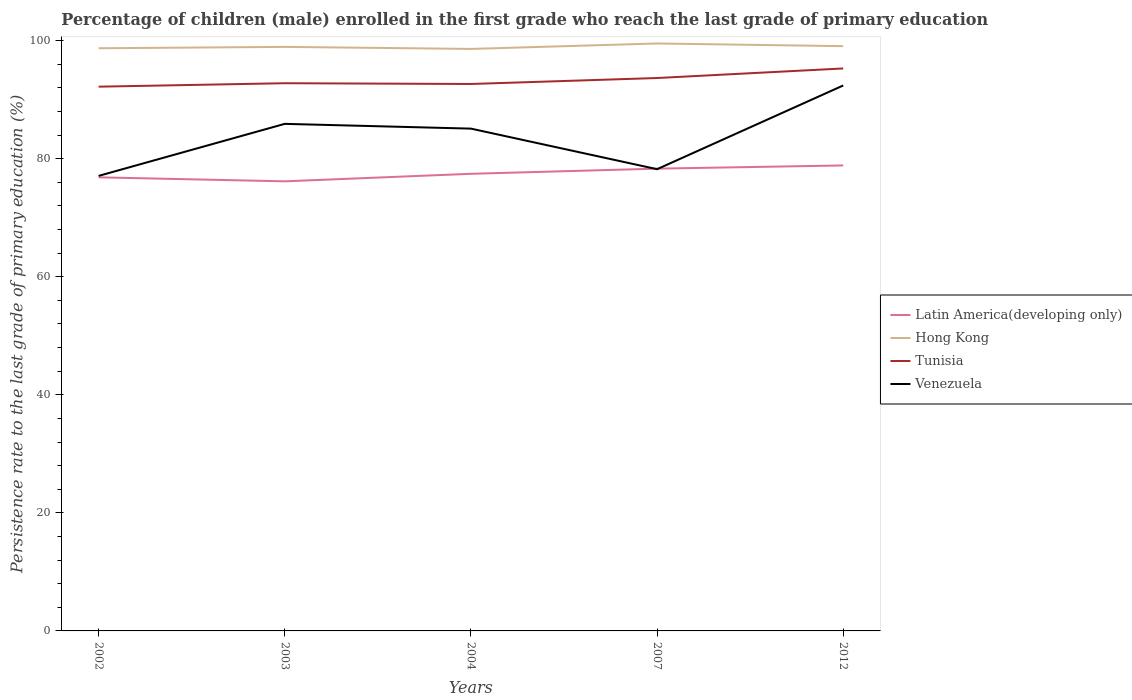Does the line corresponding to Venezuela intersect with the line corresponding to Latin America(developing only)?
Your answer should be very brief. Yes. Is the number of lines equal to the number of legend labels?
Offer a terse response. Yes. Across all years, what is the maximum persistence rate of children in Latin America(developing only)?
Keep it short and to the point. 76.17. What is the total persistence rate of children in Hong Kong in the graph?
Provide a succinct answer. -0.47. What is the difference between the highest and the second highest persistence rate of children in Tunisia?
Offer a terse response. 3.09. What is the difference between the highest and the lowest persistence rate of children in Hong Kong?
Ensure brevity in your answer.  2. Is the persistence rate of children in Latin America(developing only) strictly greater than the persistence rate of children in Venezuela over the years?
Offer a terse response. No. Are the values on the major ticks of Y-axis written in scientific E-notation?
Provide a succinct answer. No. Does the graph contain any zero values?
Keep it short and to the point. No. How many legend labels are there?
Keep it short and to the point. 4. What is the title of the graph?
Offer a very short reply. Percentage of children (male) enrolled in the first grade who reach the last grade of primary education. What is the label or title of the X-axis?
Keep it short and to the point. Years. What is the label or title of the Y-axis?
Your answer should be compact. Persistence rate to the last grade of primary education (%). What is the Persistence rate to the last grade of primary education (%) in Latin America(developing only) in 2002?
Ensure brevity in your answer.  76.84. What is the Persistence rate to the last grade of primary education (%) in Hong Kong in 2002?
Provide a succinct answer. 98.71. What is the Persistence rate to the last grade of primary education (%) in Tunisia in 2002?
Make the answer very short. 92.2. What is the Persistence rate to the last grade of primary education (%) in Venezuela in 2002?
Your response must be concise. 77.09. What is the Persistence rate to the last grade of primary education (%) in Latin America(developing only) in 2003?
Keep it short and to the point. 76.17. What is the Persistence rate to the last grade of primary education (%) of Hong Kong in 2003?
Your answer should be very brief. 98.94. What is the Persistence rate to the last grade of primary education (%) in Tunisia in 2003?
Your answer should be compact. 92.79. What is the Persistence rate to the last grade of primary education (%) of Venezuela in 2003?
Offer a terse response. 85.9. What is the Persistence rate to the last grade of primary education (%) in Latin America(developing only) in 2004?
Your answer should be compact. 77.44. What is the Persistence rate to the last grade of primary education (%) of Hong Kong in 2004?
Provide a short and direct response. 98.6. What is the Persistence rate to the last grade of primary education (%) in Tunisia in 2004?
Offer a terse response. 92.66. What is the Persistence rate to the last grade of primary education (%) in Venezuela in 2004?
Your answer should be very brief. 85.1. What is the Persistence rate to the last grade of primary education (%) of Latin America(developing only) in 2007?
Keep it short and to the point. 78.32. What is the Persistence rate to the last grade of primary education (%) in Hong Kong in 2007?
Your answer should be compact. 99.52. What is the Persistence rate to the last grade of primary education (%) in Tunisia in 2007?
Your response must be concise. 93.67. What is the Persistence rate to the last grade of primary education (%) of Venezuela in 2007?
Ensure brevity in your answer.  78.22. What is the Persistence rate to the last grade of primary education (%) of Latin America(developing only) in 2012?
Your response must be concise. 78.86. What is the Persistence rate to the last grade of primary education (%) in Hong Kong in 2012?
Provide a short and direct response. 99.07. What is the Persistence rate to the last grade of primary education (%) of Tunisia in 2012?
Provide a short and direct response. 95.29. What is the Persistence rate to the last grade of primary education (%) of Venezuela in 2012?
Keep it short and to the point. 92.41. Across all years, what is the maximum Persistence rate to the last grade of primary education (%) of Latin America(developing only)?
Make the answer very short. 78.86. Across all years, what is the maximum Persistence rate to the last grade of primary education (%) in Hong Kong?
Keep it short and to the point. 99.52. Across all years, what is the maximum Persistence rate to the last grade of primary education (%) in Tunisia?
Keep it short and to the point. 95.29. Across all years, what is the maximum Persistence rate to the last grade of primary education (%) of Venezuela?
Provide a short and direct response. 92.41. Across all years, what is the minimum Persistence rate to the last grade of primary education (%) of Latin America(developing only)?
Your answer should be very brief. 76.17. Across all years, what is the minimum Persistence rate to the last grade of primary education (%) of Hong Kong?
Your answer should be compact. 98.6. Across all years, what is the minimum Persistence rate to the last grade of primary education (%) in Tunisia?
Make the answer very short. 92.2. Across all years, what is the minimum Persistence rate to the last grade of primary education (%) in Venezuela?
Keep it short and to the point. 77.09. What is the total Persistence rate to the last grade of primary education (%) in Latin America(developing only) in the graph?
Offer a very short reply. 387.63. What is the total Persistence rate to the last grade of primary education (%) in Hong Kong in the graph?
Your answer should be compact. 494.84. What is the total Persistence rate to the last grade of primary education (%) of Tunisia in the graph?
Give a very brief answer. 466.61. What is the total Persistence rate to the last grade of primary education (%) in Venezuela in the graph?
Your answer should be compact. 418.72. What is the difference between the Persistence rate to the last grade of primary education (%) in Latin America(developing only) in 2002 and that in 2003?
Your answer should be compact. 0.68. What is the difference between the Persistence rate to the last grade of primary education (%) in Hong Kong in 2002 and that in 2003?
Your response must be concise. -0.23. What is the difference between the Persistence rate to the last grade of primary education (%) in Tunisia in 2002 and that in 2003?
Your answer should be very brief. -0.58. What is the difference between the Persistence rate to the last grade of primary education (%) of Venezuela in 2002 and that in 2003?
Your response must be concise. -8.81. What is the difference between the Persistence rate to the last grade of primary education (%) in Latin America(developing only) in 2002 and that in 2004?
Provide a succinct answer. -0.6. What is the difference between the Persistence rate to the last grade of primary education (%) of Hong Kong in 2002 and that in 2004?
Give a very brief answer. 0.11. What is the difference between the Persistence rate to the last grade of primary education (%) in Tunisia in 2002 and that in 2004?
Offer a very short reply. -0.46. What is the difference between the Persistence rate to the last grade of primary education (%) in Venezuela in 2002 and that in 2004?
Provide a succinct answer. -8.01. What is the difference between the Persistence rate to the last grade of primary education (%) in Latin America(developing only) in 2002 and that in 2007?
Provide a succinct answer. -1.47. What is the difference between the Persistence rate to the last grade of primary education (%) in Hong Kong in 2002 and that in 2007?
Offer a very short reply. -0.81. What is the difference between the Persistence rate to the last grade of primary education (%) of Tunisia in 2002 and that in 2007?
Give a very brief answer. -1.47. What is the difference between the Persistence rate to the last grade of primary education (%) in Venezuela in 2002 and that in 2007?
Keep it short and to the point. -1.13. What is the difference between the Persistence rate to the last grade of primary education (%) of Latin America(developing only) in 2002 and that in 2012?
Offer a very short reply. -2.02. What is the difference between the Persistence rate to the last grade of primary education (%) of Hong Kong in 2002 and that in 2012?
Your answer should be compact. -0.35. What is the difference between the Persistence rate to the last grade of primary education (%) of Tunisia in 2002 and that in 2012?
Offer a very short reply. -3.09. What is the difference between the Persistence rate to the last grade of primary education (%) in Venezuela in 2002 and that in 2012?
Give a very brief answer. -15.32. What is the difference between the Persistence rate to the last grade of primary education (%) of Latin America(developing only) in 2003 and that in 2004?
Give a very brief answer. -1.28. What is the difference between the Persistence rate to the last grade of primary education (%) in Hong Kong in 2003 and that in 2004?
Make the answer very short. 0.34. What is the difference between the Persistence rate to the last grade of primary education (%) of Tunisia in 2003 and that in 2004?
Provide a short and direct response. 0.13. What is the difference between the Persistence rate to the last grade of primary education (%) in Venezuela in 2003 and that in 2004?
Keep it short and to the point. 0.81. What is the difference between the Persistence rate to the last grade of primary education (%) of Latin America(developing only) in 2003 and that in 2007?
Ensure brevity in your answer.  -2.15. What is the difference between the Persistence rate to the last grade of primary education (%) in Hong Kong in 2003 and that in 2007?
Offer a very short reply. -0.58. What is the difference between the Persistence rate to the last grade of primary education (%) of Tunisia in 2003 and that in 2007?
Your response must be concise. -0.88. What is the difference between the Persistence rate to the last grade of primary education (%) of Venezuela in 2003 and that in 2007?
Ensure brevity in your answer.  7.68. What is the difference between the Persistence rate to the last grade of primary education (%) in Latin America(developing only) in 2003 and that in 2012?
Your answer should be very brief. -2.69. What is the difference between the Persistence rate to the last grade of primary education (%) of Hong Kong in 2003 and that in 2012?
Your answer should be very brief. -0.12. What is the difference between the Persistence rate to the last grade of primary education (%) of Tunisia in 2003 and that in 2012?
Your answer should be compact. -2.5. What is the difference between the Persistence rate to the last grade of primary education (%) in Venezuela in 2003 and that in 2012?
Provide a short and direct response. -6.5. What is the difference between the Persistence rate to the last grade of primary education (%) in Latin America(developing only) in 2004 and that in 2007?
Your answer should be compact. -0.87. What is the difference between the Persistence rate to the last grade of primary education (%) in Hong Kong in 2004 and that in 2007?
Give a very brief answer. -0.92. What is the difference between the Persistence rate to the last grade of primary education (%) of Tunisia in 2004 and that in 2007?
Provide a succinct answer. -1.01. What is the difference between the Persistence rate to the last grade of primary education (%) of Venezuela in 2004 and that in 2007?
Keep it short and to the point. 6.87. What is the difference between the Persistence rate to the last grade of primary education (%) of Latin America(developing only) in 2004 and that in 2012?
Provide a succinct answer. -1.42. What is the difference between the Persistence rate to the last grade of primary education (%) in Hong Kong in 2004 and that in 2012?
Keep it short and to the point. -0.47. What is the difference between the Persistence rate to the last grade of primary education (%) in Tunisia in 2004 and that in 2012?
Provide a short and direct response. -2.63. What is the difference between the Persistence rate to the last grade of primary education (%) in Venezuela in 2004 and that in 2012?
Offer a very short reply. -7.31. What is the difference between the Persistence rate to the last grade of primary education (%) of Latin America(developing only) in 2007 and that in 2012?
Give a very brief answer. -0.54. What is the difference between the Persistence rate to the last grade of primary education (%) in Hong Kong in 2007 and that in 2012?
Your answer should be compact. 0.46. What is the difference between the Persistence rate to the last grade of primary education (%) in Tunisia in 2007 and that in 2012?
Your answer should be compact. -1.62. What is the difference between the Persistence rate to the last grade of primary education (%) in Venezuela in 2007 and that in 2012?
Ensure brevity in your answer.  -14.18. What is the difference between the Persistence rate to the last grade of primary education (%) of Latin America(developing only) in 2002 and the Persistence rate to the last grade of primary education (%) of Hong Kong in 2003?
Offer a terse response. -22.1. What is the difference between the Persistence rate to the last grade of primary education (%) of Latin America(developing only) in 2002 and the Persistence rate to the last grade of primary education (%) of Tunisia in 2003?
Your answer should be compact. -15.94. What is the difference between the Persistence rate to the last grade of primary education (%) of Latin America(developing only) in 2002 and the Persistence rate to the last grade of primary education (%) of Venezuela in 2003?
Your answer should be compact. -9.06. What is the difference between the Persistence rate to the last grade of primary education (%) in Hong Kong in 2002 and the Persistence rate to the last grade of primary education (%) in Tunisia in 2003?
Your response must be concise. 5.92. What is the difference between the Persistence rate to the last grade of primary education (%) in Hong Kong in 2002 and the Persistence rate to the last grade of primary education (%) in Venezuela in 2003?
Ensure brevity in your answer.  12.81. What is the difference between the Persistence rate to the last grade of primary education (%) of Tunisia in 2002 and the Persistence rate to the last grade of primary education (%) of Venezuela in 2003?
Your response must be concise. 6.3. What is the difference between the Persistence rate to the last grade of primary education (%) of Latin America(developing only) in 2002 and the Persistence rate to the last grade of primary education (%) of Hong Kong in 2004?
Give a very brief answer. -21.76. What is the difference between the Persistence rate to the last grade of primary education (%) in Latin America(developing only) in 2002 and the Persistence rate to the last grade of primary education (%) in Tunisia in 2004?
Offer a very short reply. -15.81. What is the difference between the Persistence rate to the last grade of primary education (%) in Latin America(developing only) in 2002 and the Persistence rate to the last grade of primary education (%) in Venezuela in 2004?
Offer a terse response. -8.25. What is the difference between the Persistence rate to the last grade of primary education (%) in Hong Kong in 2002 and the Persistence rate to the last grade of primary education (%) in Tunisia in 2004?
Offer a terse response. 6.05. What is the difference between the Persistence rate to the last grade of primary education (%) in Hong Kong in 2002 and the Persistence rate to the last grade of primary education (%) in Venezuela in 2004?
Offer a very short reply. 13.61. What is the difference between the Persistence rate to the last grade of primary education (%) in Tunisia in 2002 and the Persistence rate to the last grade of primary education (%) in Venezuela in 2004?
Make the answer very short. 7.11. What is the difference between the Persistence rate to the last grade of primary education (%) of Latin America(developing only) in 2002 and the Persistence rate to the last grade of primary education (%) of Hong Kong in 2007?
Ensure brevity in your answer.  -22.68. What is the difference between the Persistence rate to the last grade of primary education (%) of Latin America(developing only) in 2002 and the Persistence rate to the last grade of primary education (%) of Tunisia in 2007?
Your response must be concise. -16.83. What is the difference between the Persistence rate to the last grade of primary education (%) in Latin America(developing only) in 2002 and the Persistence rate to the last grade of primary education (%) in Venezuela in 2007?
Offer a very short reply. -1.38. What is the difference between the Persistence rate to the last grade of primary education (%) in Hong Kong in 2002 and the Persistence rate to the last grade of primary education (%) in Tunisia in 2007?
Your answer should be very brief. 5.04. What is the difference between the Persistence rate to the last grade of primary education (%) in Hong Kong in 2002 and the Persistence rate to the last grade of primary education (%) in Venezuela in 2007?
Ensure brevity in your answer.  20.49. What is the difference between the Persistence rate to the last grade of primary education (%) of Tunisia in 2002 and the Persistence rate to the last grade of primary education (%) of Venezuela in 2007?
Keep it short and to the point. 13.98. What is the difference between the Persistence rate to the last grade of primary education (%) of Latin America(developing only) in 2002 and the Persistence rate to the last grade of primary education (%) of Hong Kong in 2012?
Offer a very short reply. -22.22. What is the difference between the Persistence rate to the last grade of primary education (%) of Latin America(developing only) in 2002 and the Persistence rate to the last grade of primary education (%) of Tunisia in 2012?
Your answer should be very brief. -18.45. What is the difference between the Persistence rate to the last grade of primary education (%) of Latin America(developing only) in 2002 and the Persistence rate to the last grade of primary education (%) of Venezuela in 2012?
Ensure brevity in your answer.  -15.56. What is the difference between the Persistence rate to the last grade of primary education (%) of Hong Kong in 2002 and the Persistence rate to the last grade of primary education (%) of Tunisia in 2012?
Your answer should be compact. 3.42. What is the difference between the Persistence rate to the last grade of primary education (%) in Hong Kong in 2002 and the Persistence rate to the last grade of primary education (%) in Venezuela in 2012?
Ensure brevity in your answer.  6.3. What is the difference between the Persistence rate to the last grade of primary education (%) of Tunisia in 2002 and the Persistence rate to the last grade of primary education (%) of Venezuela in 2012?
Your answer should be compact. -0.2. What is the difference between the Persistence rate to the last grade of primary education (%) of Latin America(developing only) in 2003 and the Persistence rate to the last grade of primary education (%) of Hong Kong in 2004?
Your response must be concise. -22.43. What is the difference between the Persistence rate to the last grade of primary education (%) in Latin America(developing only) in 2003 and the Persistence rate to the last grade of primary education (%) in Tunisia in 2004?
Offer a very short reply. -16.49. What is the difference between the Persistence rate to the last grade of primary education (%) in Latin America(developing only) in 2003 and the Persistence rate to the last grade of primary education (%) in Venezuela in 2004?
Your answer should be very brief. -8.93. What is the difference between the Persistence rate to the last grade of primary education (%) of Hong Kong in 2003 and the Persistence rate to the last grade of primary education (%) of Tunisia in 2004?
Offer a terse response. 6.28. What is the difference between the Persistence rate to the last grade of primary education (%) of Hong Kong in 2003 and the Persistence rate to the last grade of primary education (%) of Venezuela in 2004?
Give a very brief answer. 13.85. What is the difference between the Persistence rate to the last grade of primary education (%) of Tunisia in 2003 and the Persistence rate to the last grade of primary education (%) of Venezuela in 2004?
Provide a succinct answer. 7.69. What is the difference between the Persistence rate to the last grade of primary education (%) in Latin America(developing only) in 2003 and the Persistence rate to the last grade of primary education (%) in Hong Kong in 2007?
Your answer should be very brief. -23.36. What is the difference between the Persistence rate to the last grade of primary education (%) of Latin America(developing only) in 2003 and the Persistence rate to the last grade of primary education (%) of Tunisia in 2007?
Your response must be concise. -17.5. What is the difference between the Persistence rate to the last grade of primary education (%) of Latin America(developing only) in 2003 and the Persistence rate to the last grade of primary education (%) of Venezuela in 2007?
Keep it short and to the point. -2.06. What is the difference between the Persistence rate to the last grade of primary education (%) of Hong Kong in 2003 and the Persistence rate to the last grade of primary education (%) of Tunisia in 2007?
Offer a terse response. 5.27. What is the difference between the Persistence rate to the last grade of primary education (%) of Hong Kong in 2003 and the Persistence rate to the last grade of primary education (%) of Venezuela in 2007?
Provide a short and direct response. 20.72. What is the difference between the Persistence rate to the last grade of primary education (%) of Tunisia in 2003 and the Persistence rate to the last grade of primary education (%) of Venezuela in 2007?
Provide a short and direct response. 14.56. What is the difference between the Persistence rate to the last grade of primary education (%) in Latin America(developing only) in 2003 and the Persistence rate to the last grade of primary education (%) in Hong Kong in 2012?
Offer a very short reply. -22.9. What is the difference between the Persistence rate to the last grade of primary education (%) of Latin America(developing only) in 2003 and the Persistence rate to the last grade of primary education (%) of Tunisia in 2012?
Make the answer very short. -19.12. What is the difference between the Persistence rate to the last grade of primary education (%) in Latin America(developing only) in 2003 and the Persistence rate to the last grade of primary education (%) in Venezuela in 2012?
Ensure brevity in your answer.  -16.24. What is the difference between the Persistence rate to the last grade of primary education (%) of Hong Kong in 2003 and the Persistence rate to the last grade of primary education (%) of Tunisia in 2012?
Make the answer very short. 3.65. What is the difference between the Persistence rate to the last grade of primary education (%) in Hong Kong in 2003 and the Persistence rate to the last grade of primary education (%) in Venezuela in 2012?
Offer a terse response. 6.54. What is the difference between the Persistence rate to the last grade of primary education (%) of Tunisia in 2003 and the Persistence rate to the last grade of primary education (%) of Venezuela in 2012?
Your response must be concise. 0.38. What is the difference between the Persistence rate to the last grade of primary education (%) of Latin America(developing only) in 2004 and the Persistence rate to the last grade of primary education (%) of Hong Kong in 2007?
Offer a terse response. -22.08. What is the difference between the Persistence rate to the last grade of primary education (%) of Latin America(developing only) in 2004 and the Persistence rate to the last grade of primary education (%) of Tunisia in 2007?
Offer a terse response. -16.23. What is the difference between the Persistence rate to the last grade of primary education (%) in Latin America(developing only) in 2004 and the Persistence rate to the last grade of primary education (%) in Venezuela in 2007?
Give a very brief answer. -0.78. What is the difference between the Persistence rate to the last grade of primary education (%) in Hong Kong in 2004 and the Persistence rate to the last grade of primary education (%) in Tunisia in 2007?
Offer a terse response. 4.93. What is the difference between the Persistence rate to the last grade of primary education (%) in Hong Kong in 2004 and the Persistence rate to the last grade of primary education (%) in Venezuela in 2007?
Your response must be concise. 20.38. What is the difference between the Persistence rate to the last grade of primary education (%) in Tunisia in 2004 and the Persistence rate to the last grade of primary education (%) in Venezuela in 2007?
Ensure brevity in your answer.  14.44. What is the difference between the Persistence rate to the last grade of primary education (%) of Latin America(developing only) in 2004 and the Persistence rate to the last grade of primary education (%) of Hong Kong in 2012?
Give a very brief answer. -21.62. What is the difference between the Persistence rate to the last grade of primary education (%) of Latin America(developing only) in 2004 and the Persistence rate to the last grade of primary education (%) of Tunisia in 2012?
Provide a succinct answer. -17.85. What is the difference between the Persistence rate to the last grade of primary education (%) in Latin America(developing only) in 2004 and the Persistence rate to the last grade of primary education (%) in Venezuela in 2012?
Your answer should be compact. -14.96. What is the difference between the Persistence rate to the last grade of primary education (%) of Hong Kong in 2004 and the Persistence rate to the last grade of primary education (%) of Tunisia in 2012?
Your answer should be very brief. 3.31. What is the difference between the Persistence rate to the last grade of primary education (%) in Hong Kong in 2004 and the Persistence rate to the last grade of primary education (%) in Venezuela in 2012?
Keep it short and to the point. 6.19. What is the difference between the Persistence rate to the last grade of primary education (%) in Tunisia in 2004 and the Persistence rate to the last grade of primary education (%) in Venezuela in 2012?
Offer a terse response. 0.25. What is the difference between the Persistence rate to the last grade of primary education (%) of Latin America(developing only) in 2007 and the Persistence rate to the last grade of primary education (%) of Hong Kong in 2012?
Offer a very short reply. -20.75. What is the difference between the Persistence rate to the last grade of primary education (%) of Latin America(developing only) in 2007 and the Persistence rate to the last grade of primary education (%) of Tunisia in 2012?
Your response must be concise. -16.97. What is the difference between the Persistence rate to the last grade of primary education (%) of Latin America(developing only) in 2007 and the Persistence rate to the last grade of primary education (%) of Venezuela in 2012?
Give a very brief answer. -14.09. What is the difference between the Persistence rate to the last grade of primary education (%) of Hong Kong in 2007 and the Persistence rate to the last grade of primary education (%) of Tunisia in 2012?
Your response must be concise. 4.23. What is the difference between the Persistence rate to the last grade of primary education (%) in Hong Kong in 2007 and the Persistence rate to the last grade of primary education (%) in Venezuela in 2012?
Offer a terse response. 7.11. What is the difference between the Persistence rate to the last grade of primary education (%) in Tunisia in 2007 and the Persistence rate to the last grade of primary education (%) in Venezuela in 2012?
Provide a short and direct response. 1.26. What is the average Persistence rate to the last grade of primary education (%) of Latin America(developing only) per year?
Your response must be concise. 77.53. What is the average Persistence rate to the last grade of primary education (%) in Hong Kong per year?
Make the answer very short. 98.97. What is the average Persistence rate to the last grade of primary education (%) in Tunisia per year?
Offer a very short reply. 93.32. What is the average Persistence rate to the last grade of primary education (%) in Venezuela per year?
Make the answer very short. 83.74. In the year 2002, what is the difference between the Persistence rate to the last grade of primary education (%) of Latin America(developing only) and Persistence rate to the last grade of primary education (%) of Hong Kong?
Your answer should be compact. -21.87. In the year 2002, what is the difference between the Persistence rate to the last grade of primary education (%) of Latin America(developing only) and Persistence rate to the last grade of primary education (%) of Tunisia?
Keep it short and to the point. -15.36. In the year 2002, what is the difference between the Persistence rate to the last grade of primary education (%) in Latin America(developing only) and Persistence rate to the last grade of primary education (%) in Venezuela?
Offer a very short reply. -0.25. In the year 2002, what is the difference between the Persistence rate to the last grade of primary education (%) of Hong Kong and Persistence rate to the last grade of primary education (%) of Tunisia?
Keep it short and to the point. 6.51. In the year 2002, what is the difference between the Persistence rate to the last grade of primary education (%) of Hong Kong and Persistence rate to the last grade of primary education (%) of Venezuela?
Your answer should be very brief. 21.62. In the year 2002, what is the difference between the Persistence rate to the last grade of primary education (%) of Tunisia and Persistence rate to the last grade of primary education (%) of Venezuela?
Make the answer very short. 15.11. In the year 2003, what is the difference between the Persistence rate to the last grade of primary education (%) of Latin America(developing only) and Persistence rate to the last grade of primary education (%) of Hong Kong?
Your answer should be compact. -22.78. In the year 2003, what is the difference between the Persistence rate to the last grade of primary education (%) of Latin America(developing only) and Persistence rate to the last grade of primary education (%) of Tunisia?
Make the answer very short. -16.62. In the year 2003, what is the difference between the Persistence rate to the last grade of primary education (%) in Latin America(developing only) and Persistence rate to the last grade of primary education (%) in Venezuela?
Provide a succinct answer. -9.74. In the year 2003, what is the difference between the Persistence rate to the last grade of primary education (%) in Hong Kong and Persistence rate to the last grade of primary education (%) in Tunisia?
Make the answer very short. 6.16. In the year 2003, what is the difference between the Persistence rate to the last grade of primary education (%) of Hong Kong and Persistence rate to the last grade of primary education (%) of Venezuela?
Offer a very short reply. 13.04. In the year 2003, what is the difference between the Persistence rate to the last grade of primary education (%) in Tunisia and Persistence rate to the last grade of primary education (%) in Venezuela?
Offer a terse response. 6.88. In the year 2004, what is the difference between the Persistence rate to the last grade of primary education (%) in Latin America(developing only) and Persistence rate to the last grade of primary education (%) in Hong Kong?
Your answer should be compact. -21.15. In the year 2004, what is the difference between the Persistence rate to the last grade of primary education (%) in Latin America(developing only) and Persistence rate to the last grade of primary education (%) in Tunisia?
Your response must be concise. -15.21. In the year 2004, what is the difference between the Persistence rate to the last grade of primary education (%) in Latin America(developing only) and Persistence rate to the last grade of primary education (%) in Venezuela?
Offer a terse response. -7.65. In the year 2004, what is the difference between the Persistence rate to the last grade of primary education (%) of Hong Kong and Persistence rate to the last grade of primary education (%) of Tunisia?
Provide a short and direct response. 5.94. In the year 2004, what is the difference between the Persistence rate to the last grade of primary education (%) of Hong Kong and Persistence rate to the last grade of primary education (%) of Venezuela?
Make the answer very short. 13.5. In the year 2004, what is the difference between the Persistence rate to the last grade of primary education (%) of Tunisia and Persistence rate to the last grade of primary education (%) of Venezuela?
Offer a very short reply. 7.56. In the year 2007, what is the difference between the Persistence rate to the last grade of primary education (%) of Latin America(developing only) and Persistence rate to the last grade of primary education (%) of Hong Kong?
Your answer should be compact. -21.2. In the year 2007, what is the difference between the Persistence rate to the last grade of primary education (%) of Latin America(developing only) and Persistence rate to the last grade of primary education (%) of Tunisia?
Your answer should be compact. -15.35. In the year 2007, what is the difference between the Persistence rate to the last grade of primary education (%) of Latin America(developing only) and Persistence rate to the last grade of primary education (%) of Venezuela?
Offer a very short reply. 0.09. In the year 2007, what is the difference between the Persistence rate to the last grade of primary education (%) in Hong Kong and Persistence rate to the last grade of primary education (%) in Tunisia?
Make the answer very short. 5.85. In the year 2007, what is the difference between the Persistence rate to the last grade of primary education (%) in Hong Kong and Persistence rate to the last grade of primary education (%) in Venezuela?
Your answer should be very brief. 21.3. In the year 2007, what is the difference between the Persistence rate to the last grade of primary education (%) of Tunisia and Persistence rate to the last grade of primary education (%) of Venezuela?
Your answer should be compact. 15.45. In the year 2012, what is the difference between the Persistence rate to the last grade of primary education (%) of Latin America(developing only) and Persistence rate to the last grade of primary education (%) of Hong Kong?
Your answer should be very brief. -20.21. In the year 2012, what is the difference between the Persistence rate to the last grade of primary education (%) in Latin America(developing only) and Persistence rate to the last grade of primary education (%) in Tunisia?
Your answer should be compact. -16.43. In the year 2012, what is the difference between the Persistence rate to the last grade of primary education (%) in Latin America(developing only) and Persistence rate to the last grade of primary education (%) in Venezuela?
Keep it short and to the point. -13.55. In the year 2012, what is the difference between the Persistence rate to the last grade of primary education (%) in Hong Kong and Persistence rate to the last grade of primary education (%) in Tunisia?
Make the answer very short. 3.78. In the year 2012, what is the difference between the Persistence rate to the last grade of primary education (%) of Hong Kong and Persistence rate to the last grade of primary education (%) of Venezuela?
Your response must be concise. 6.66. In the year 2012, what is the difference between the Persistence rate to the last grade of primary education (%) in Tunisia and Persistence rate to the last grade of primary education (%) in Venezuela?
Provide a short and direct response. 2.88. What is the ratio of the Persistence rate to the last grade of primary education (%) in Latin America(developing only) in 2002 to that in 2003?
Make the answer very short. 1.01. What is the ratio of the Persistence rate to the last grade of primary education (%) of Hong Kong in 2002 to that in 2003?
Your response must be concise. 1. What is the ratio of the Persistence rate to the last grade of primary education (%) in Tunisia in 2002 to that in 2003?
Ensure brevity in your answer.  0.99. What is the ratio of the Persistence rate to the last grade of primary education (%) in Venezuela in 2002 to that in 2003?
Give a very brief answer. 0.9. What is the ratio of the Persistence rate to the last grade of primary education (%) in Venezuela in 2002 to that in 2004?
Ensure brevity in your answer.  0.91. What is the ratio of the Persistence rate to the last grade of primary education (%) of Latin America(developing only) in 2002 to that in 2007?
Offer a terse response. 0.98. What is the ratio of the Persistence rate to the last grade of primary education (%) in Hong Kong in 2002 to that in 2007?
Offer a terse response. 0.99. What is the ratio of the Persistence rate to the last grade of primary education (%) in Tunisia in 2002 to that in 2007?
Provide a short and direct response. 0.98. What is the ratio of the Persistence rate to the last grade of primary education (%) in Venezuela in 2002 to that in 2007?
Offer a terse response. 0.99. What is the ratio of the Persistence rate to the last grade of primary education (%) of Latin America(developing only) in 2002 to that in 2012?
Make the answer very short. 0.97. What is the ratio of the Persistence rate to the last grade of primary education (%) of Tunisia in 2002 to that in 2012?
Offer a terse response. 0.97. What is the ratio of the Persistence rate to the last grade of primary education (%) of Venezuela in 2002 to that in 2012?
Ensure brevity in your answer.  0.83. What is the ratio of the Persistence rate to the last grade of primary education (%) in Latin America(developing only) in 2003 to that in 2004?
Ensure brevity in your answer.  0.98. What is the ratio of the Persistence rate to the last grade of primary education (%) in Venezuela in 2003 to that in 2004?
Keep it short and to the point. 1.01. What is the ratio of the Persistence rate to the last grade of primary education (%) in Latin America(developing only) in 2003 to that in 2007?
Your response must be concise. 0.97. What is the ratio of the Persistence rate to the last grade of primary education (%) of Hong Kong in 2003 to that in 2007?
Provide a succinct answer. 0.99. What is the ratio of the Persistence rate to the last grade of primary education (%) in Tunisia in 2003 to that in 2007?
Give a very brief answer. 0.99. What is the ratio of the Persistence rate to the last grade of primary education (%) in Venezuela in 2003 to that in 2007?
Offer a very short reply. 1.1. What is the ratio of the Persistence rate to the last grade of primary education (%) of Latin America(developing only) in 2003 to that in 2012?
Offer a terse response. 0.97. What is the ratio of the Persistence rate to the last grade of primary education (%) in Hong Kong in 2003 to that in 2012?
Your answer should be very brief. 1. What is the ratio of the Persistence rate to the last grade of primary education (%) in Tunisia in 2003 to that in 2012?
Your answer should be very brief. 0.97. What is the ratio of the Persistence rate to the last grade of primary education (%) in Venezuela in 2003 to that in 2012?
Provide a short and direct response. 0.93. What is the ratio of the Persistence rate to the last grade of primary education (%) of Venezuela in 2004 to that in 2007?
Ensure brevity in your answer.  1.09. What is the ratio of the Persistence rate to the last grade of primary education (%) of Tunisia in 2004 to that in 2012?
Keep it short and to the point. 0.97. What is the ratio of the Persistence rate to the last grade of primary education (%) in Venezuela in 2004 to that in 2012?
Make the answer very short. 0.92. What is the ratio of the Persistence rate to the last grade of primary education (%) in Latin America(developing only) in 2007 to that in 2012?
Make the answer very short. 0.99. What is the ratio of the Persistence rate to the last grade of primary education (%) of Tunisia in 2007 to that in 2012?
Provide a short and direct response. 0.98. What is the ratio of the Persistence rate to the last grade of primary education (%) of Venezuela in 2007 to that in 2012?
Make the answer very short. 0.85. What is the difference between the highest and the second highest Persistence rate to the last grade of primary education (%) of Latin America(developing only)?
Give a very brief answer. 0.54. What is the difference between the highest and the second highest Persistence rate to the last grade of primary education (%) in Hong Kong?
Your answer should be compact. 0.46. What is the difference between the highest and the second highest Persistence rate to the last grade of primary education (%) in Tunisia?
Provide a short and direct response. 1.62. What is the difference between the highest and the second highest Persistence rate to the last grade of primary education (%) of Venezuela?
Keep it short and to the point. 6.5. What is the difference between the highest and the lowest Persistence rate to the last grade of primary education (%) of Latin America(developing only)?
Offer a terse response. 2.69. What is the difference between the highest and the lowest Persistence rate to the last grade of primary education (%) of Hong Kong?
Keep it short and to the point. 0.92. What is the difference between the highest and the lowest Persistence rate to the last grade of primary education (%) in Tunisia?
Offer a terse response. 3.09. What is the difference between the highest and the lowest Persistence rate to the last grade of primary education (%) of Venezuela?
Provide a short and direct response. 15.32. 